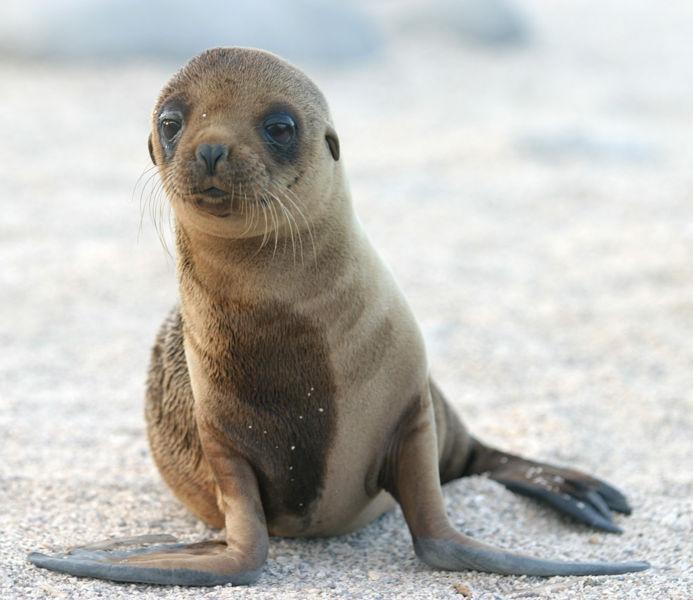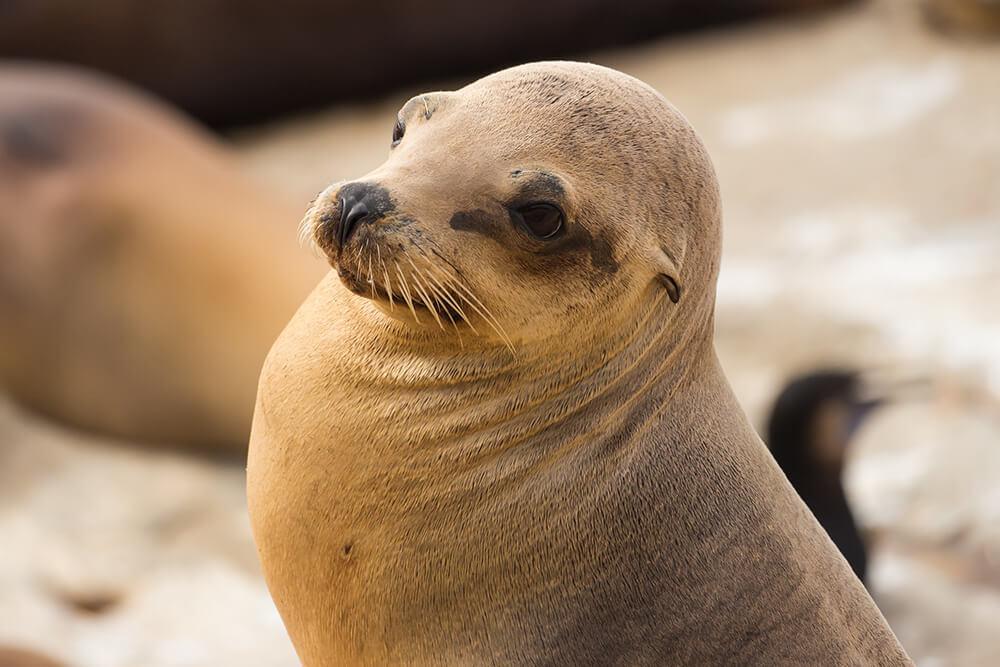The first image is the image on the left, the second image is the image on the right. Examine the images to the left and right. Is the description "There is 1 seal near waves on a sunny day." accurate? Answer yes or no. No. The first image is the image on the left, the second image is the image on the right. Evaluate the accuracy of this statement regarding the images: "An image shows a seal with body in profile and water visible.". Is it true? Answer yes or no. No. 